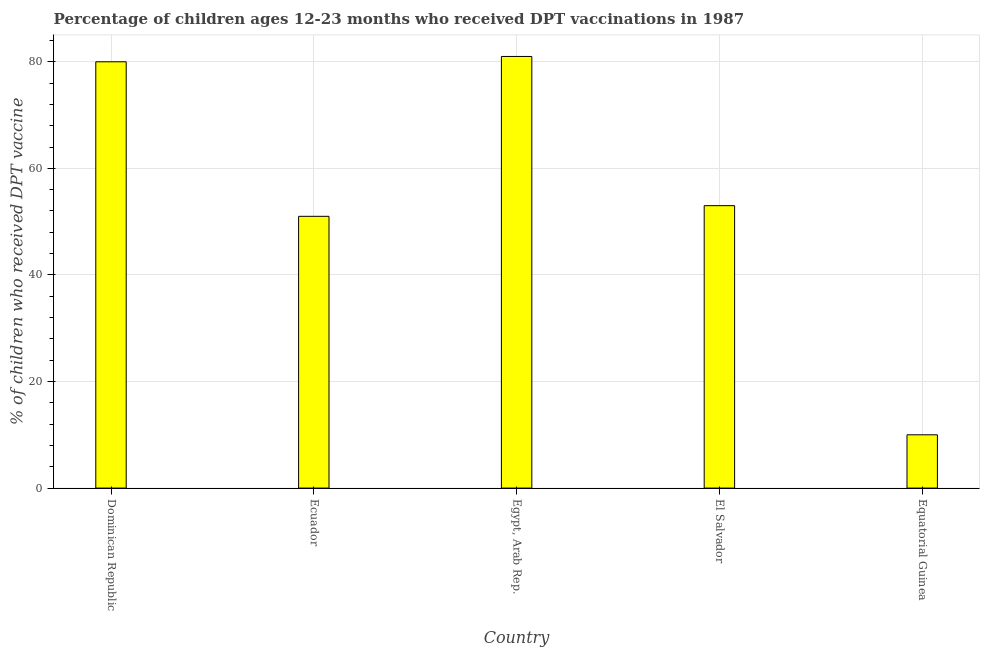Does the graph contain any zero values?
Offer a very short reply. No. Does the graph contain grids?
Make the answer very short. Yes. What is the title of the graph?
Keep it short and to the point. Percentage of children ages 12-23 months who received DPT vaccinations in 1987. What is the label or title of the Y-axis?
Ensure brevity in your answer.  % of children who received DPT vaccine. Across all countries, what is the minimum percentage of children who received dpt vaccine?
Make the answer very short. 10. In which country was the percentage of children who received dpt vaccine maximum?
Keep it short and to the point. Egypt, Arab Rep. In which country was the percentage of children who received dpt vaccine minimum?
Your answer should be very brief. Equatorial Guinea. What is the sum of the percentage of children who received dpt vaccine?
Keep it short and to the point. 275. What is the difference between the percentage of children who received dpt vaccine in Dominican Republic and Ecuador?
Offer a very short reply. 29. What is the average percentage of children who received dpt vaccine per country?
Your answer should be very brief. 55. Is the percentage of children who received dpt vaccine in Dominican Republic less than that in Egypt, Arab Rep.?
Keep it short and to the point. Yes. Is the difference between the percentage of children who received dpt vaccine in Dominican Republic and Equatorial Guinea greater than the difference between any two countries?
Offer a very short reply. No. In how many countries, is the percentage of children who received dpt vaccine greater than the average percentage of children who received dpt vaccine taken over all countries?
Your answer should be very brief. 2. Are all the bars in the graph horizontal?
Make the answer very short. No. How many countries are there in the graph?
Provide a succinct answer. 5. What is the difference between two consecutive major ticks on the Y-axis?
Ensure brevity in your answer.  20. What is the % of children who received DPT vaccine of Dominican Republic?
Provide a succinct answer. 80. What is the % of children who received DPT vaccine of El Salvador?
Offer a terse response. 53. What is the difference between the % of children who received DPT vaccine in Dominican Republic and Ecuador?
Provide a short and direct response. 29. What is the difference between the % of children who received DPT vaccine in Ecuador and Egypt, Arab Rep.?
Offer a terse response. -30. What is the difference between the % of children who received DPT vaccine in Ecuador and El Salvador?
Provide a short and direct response. -2. What is the difference between the % of children who received DPT vaccine in Egypt, Arab Rep. and El Salvador?
Your answer should be very brief. 28. What is the difference between the % of children who received DPT vaccine in El Salvador and Equatorial Guinea?
Give a very brief answer. 43. What is the ratio of the % of children who received DPT vaccine in Dominican Republic to that in Ecuador?
Provide a short and direct response. 1.57. What is the ratio of the % of children who received DPT vaccine in Dominican Republic to that in El Salvador?
Provide a short and direct response. 1.51. What is the ratio of the % of children who received DPT vaccine in Dominican Republic to that in Equatorial Guinea?
Make the answer very short. 8. What is the ratio of the % of children who received DPT vaccine in Ecuador to that in Egypt, Arab Rep.?
Make the answer very short. 0.63. What is the ratio of the % of children who received DPT vaccine in Ecuador to that in Equatorial Guinea?
Keep it short and to the point. 5.1. What is the ratio of the % of children who received DPT vaccine in Egypt, Arab Rep. to that in El Salvador?
Your response must be concise. 1.53. 